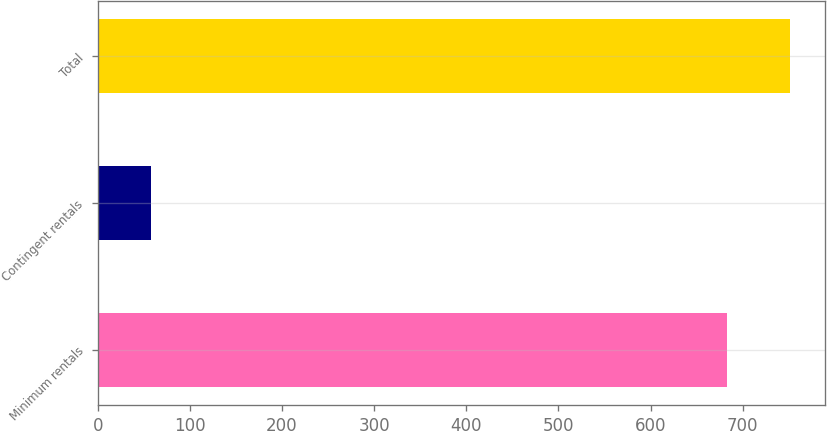<chart> <loc_0><loc_0><loc_500><loc_500><bar_chart><fcel>Minimum rentals<fcel>Contingent rentals<fcel>Total<nl><fcel>683.4<fcel>57.7<fcel>751.74<nl></chart> 